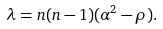Convert formula to latex. <formula><loc_0><loc_0><loc_500><loc_500>\lambda = n ( n - 1 ) ( \alpha ^ { 2 } - \rho ) .</formula> 